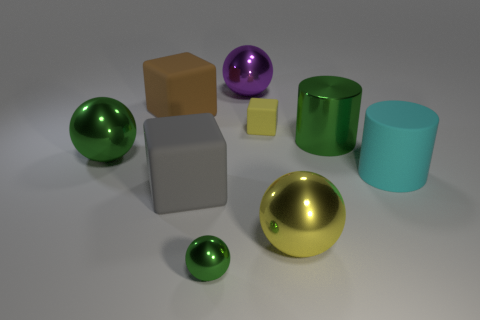The small cube is what color?
Provide a succinct answer. Yellow. There is a tiny object that is the same shape as the large gray rubber object; what is its color?
Offer a very short reply. Yellow. Does the big purple object have the same shape as the cyan rubber thing?
Your answer should be very brief. No. How many cylinders are either tiny shiny objects or large yellow shiny objects?
Provide a short and direct response. 0. The other tiny block that is made of the same material as the gray cube is what color?
Keep it short and to the point. Yellow. There is a green sphere that is in front of the yellow metal sphere; is it the same size as the large brown matte thing?
Keep it short and to the point. No. Do the green cylinder and the yellow thing that is behind the gray matte object have the same material?
Your answer should be compact. No. There is a big matte block that is behind the yellow rubber object; what is its color?
Your response must be concise. Brown. There is a large green thing that is in front of the big green cylinder; is there a green object that is behind it?
Your answer should be very brief. Yes. Is the color of the ball in front of the large yellow object the same as the big metal ball on the left side of the large purple object?
Your answer should be very brief. Yes. 